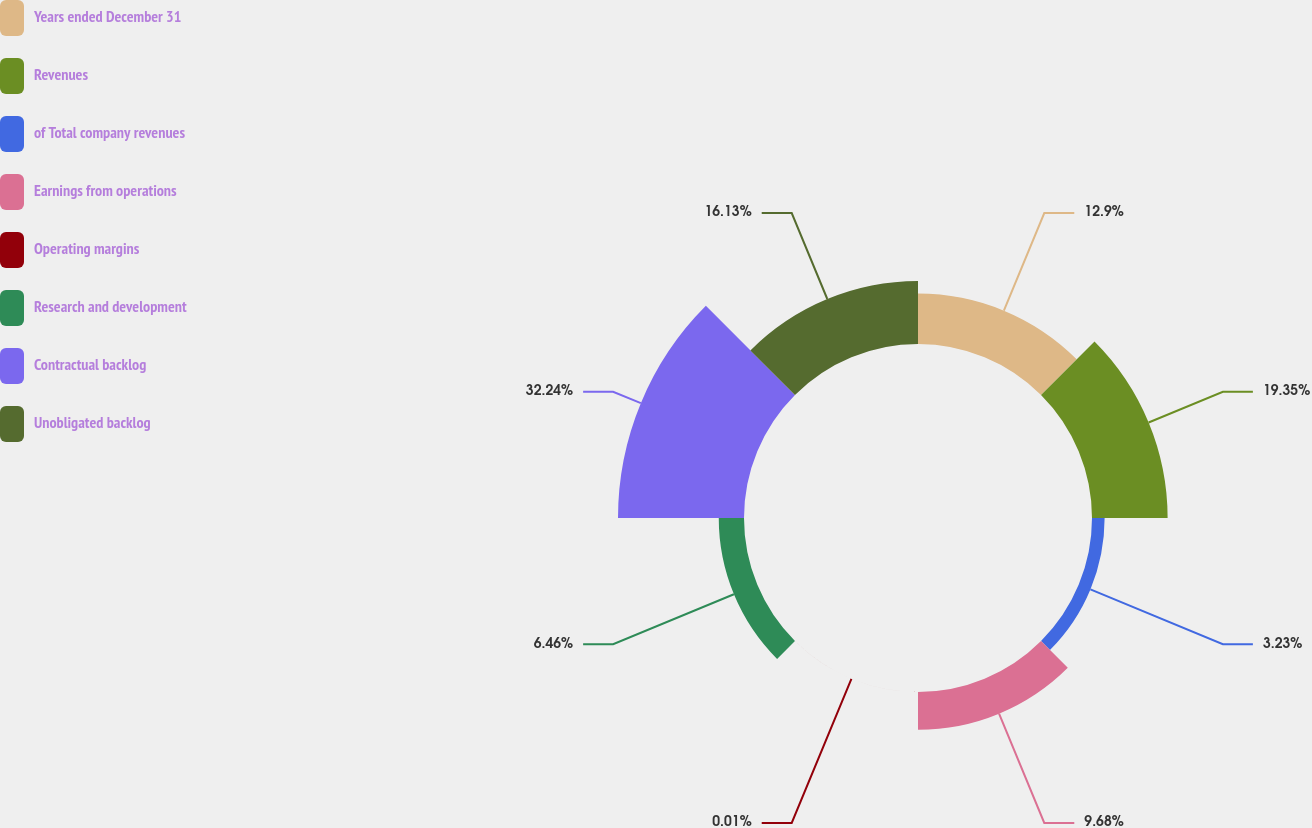Convert chart. <chart><loc_0><loc_0><loc_500><loc_500><pie_chart><fcel>Years ended December 31<fcel>Revenues<fcel>of Total company revenues<fcel>Earnings from operations<fcel>Operating margins<fcel>Research and development<fcel>Contractual backlog<fcel>Unobligated backlog<nl><fcel>12.9%<fcel>19.35%<fcel>3.23%<fcel>9.68%<fcel>0.01%<fcel>6.46%<fcel>32.24%<fcel>16.13%<nl></chart> 